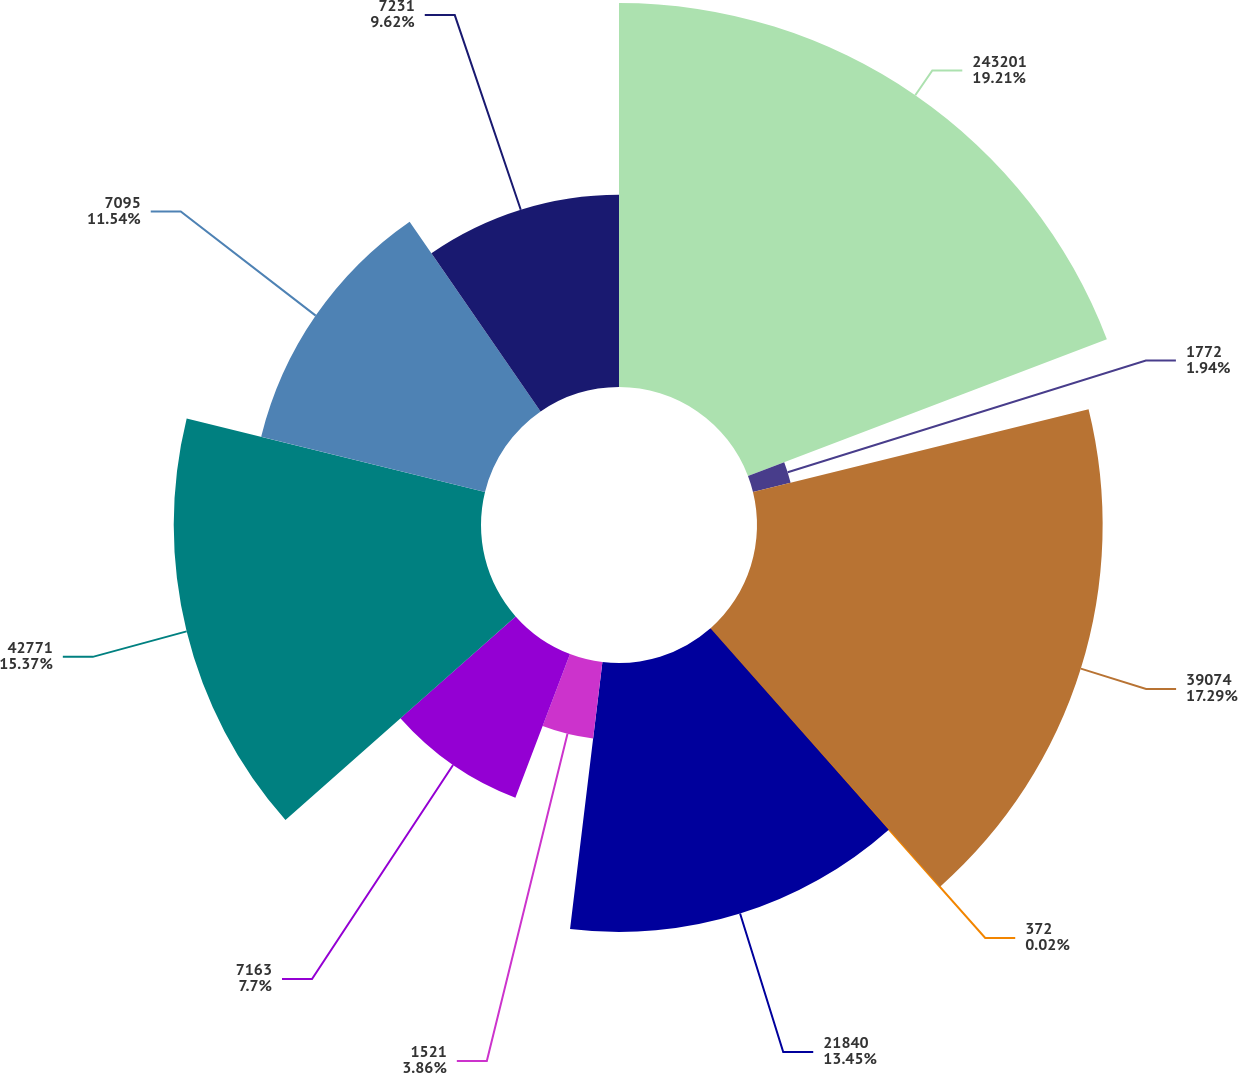Convert chart. <chart><loc_0><loc_0><loc_500><loc_500><pie_chart><fcel>243201<fcel>1772<fcel>39074<fcel>372<fcel>21840<fcel>1521<fcel>7163<fcel>42771<fcel>7095<fcel>7231<nl><fcel>19.22%<fcel>1.94%<fcel>17.3%<fcel>0.02%<fcel>13.46%<fcel>3.86%<fcel>7.7%<fcel>15.38%<fcel>11.54%<fcel>9.62%<nl></chart> 